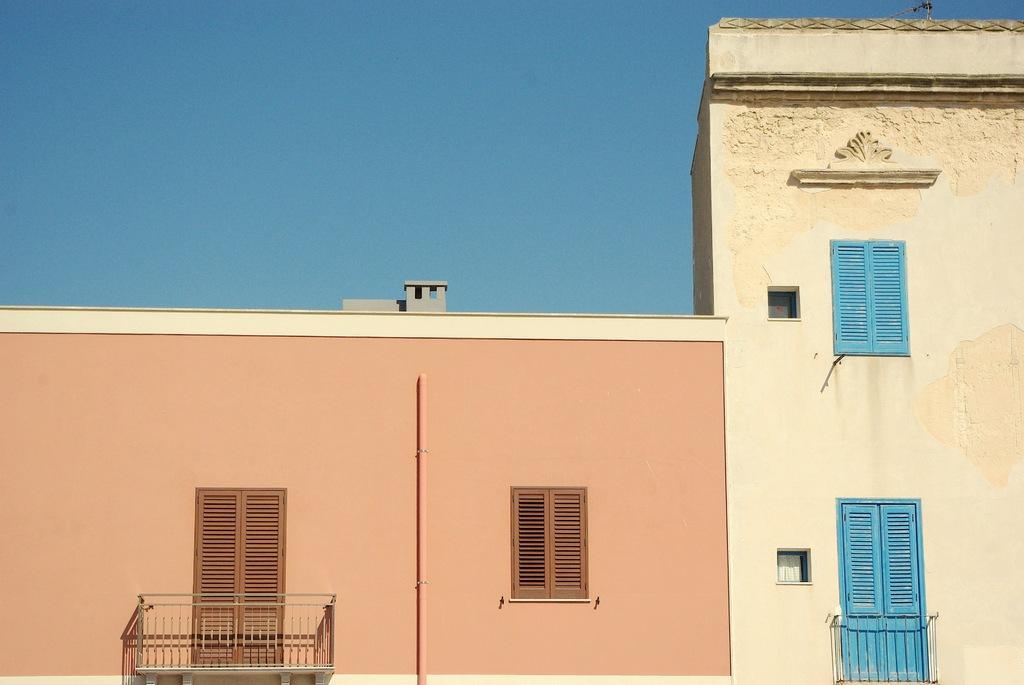Describe this image in one or two sentences. In this image in front there is a building with the windows. In front of the windows there is a metal fence. In the background there is the sky. 